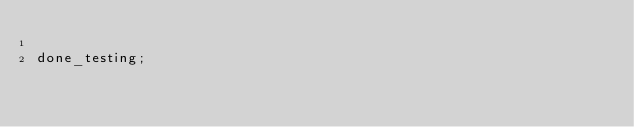Convert code to text. <code><loc_0><loc_0><loc_500><loc_500><_Perl_>
done_testing;
</code> 